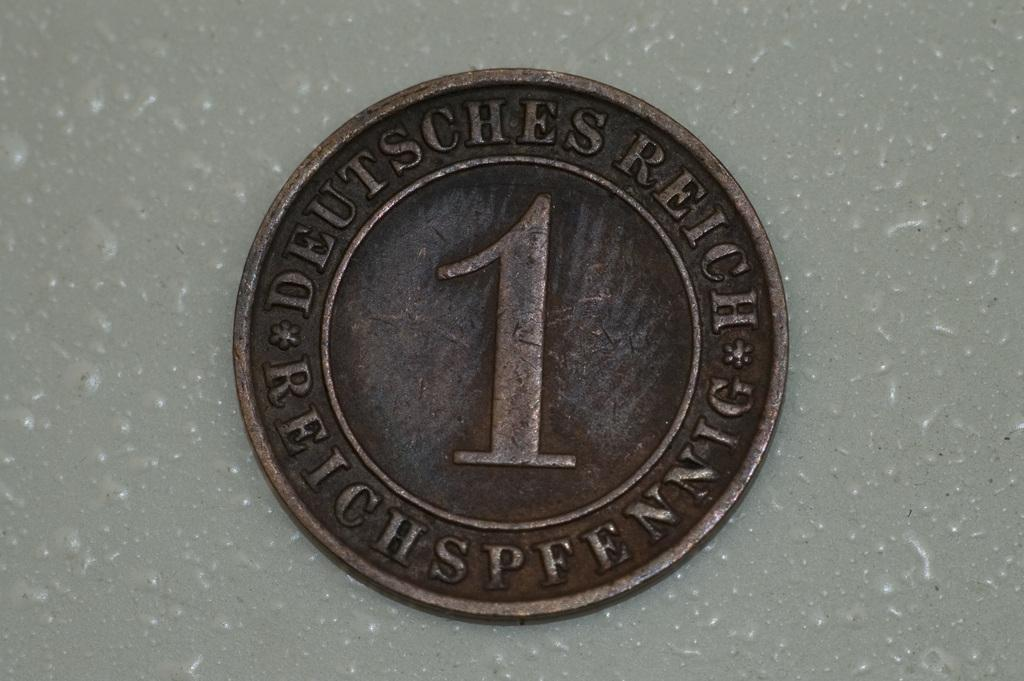<image>
Render a clear and concise summary of the photo. A coin that says "Deutsches" around the edge has a big number one on it. 